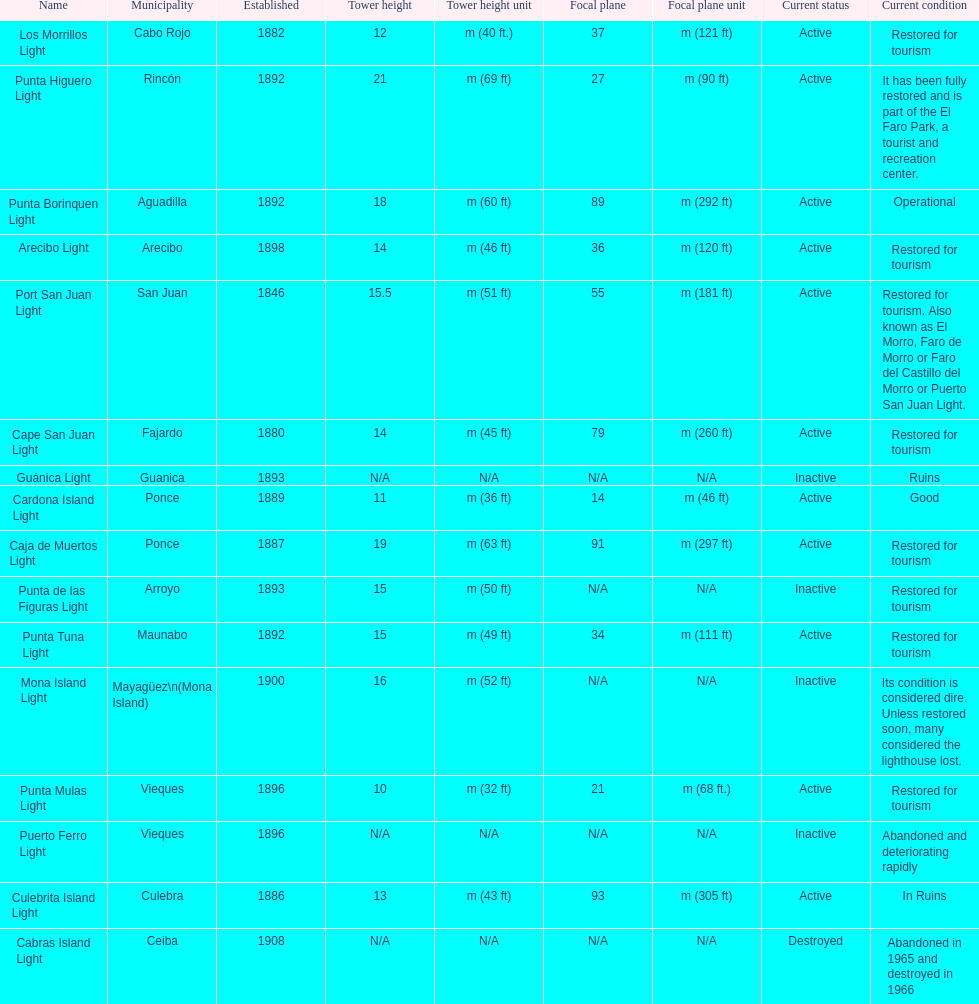How many establishments are restored for tourism? 9. 